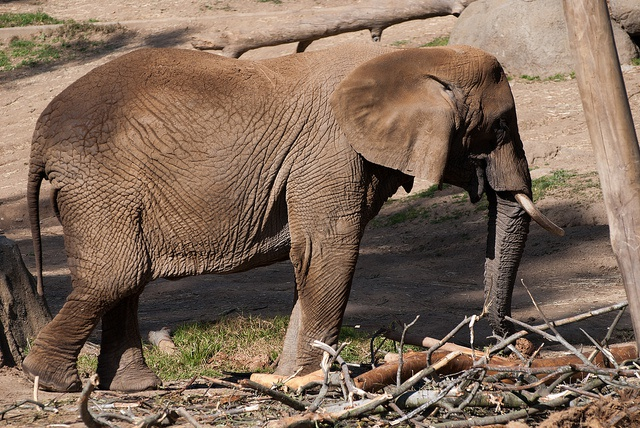Describe the objects in this image and their specific colors. I can see a elephant in black, gray, and tan tones in this image. 